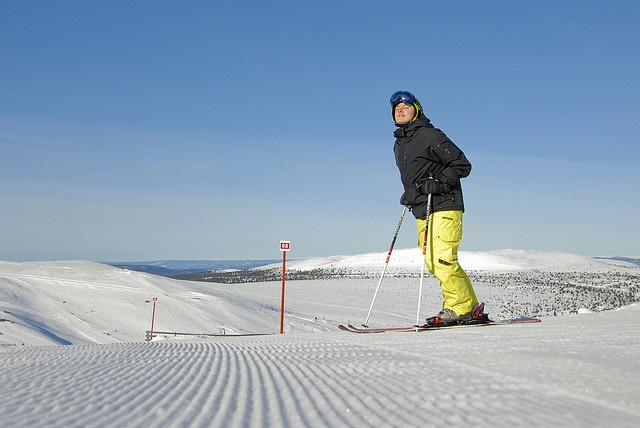Describe the objects in this image and their specific colors. I can see people in gray, black, and khaki tones, skis in gray, darkgray, lightgray, and brown tones, and skis in gray, brown, lightgray, and darkgray tones in this image. 